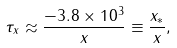<formula> <loc_0><loc_0><loc_500><loc_500>\tau _ { x } \approx \frac { - 3 . 8 \times 1 0 ^ { 3 } } { x } \equiv \frac { x _ { * } } { x } ,</formula> 